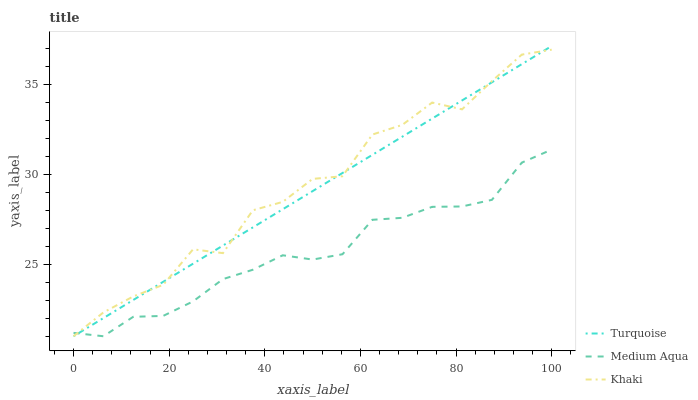Does Medium Aqua have the minimum area under the curve?
Answer yes or no. Yes. Does Khaki have the maximum area under the curve?
Answer yes or no. Yes. Does Khaki have the minimum area under the curve?
Answer yes or no. No. Does Medium Aqua have the maximum area under the curve?
Answer yes or no. No. Is Turquoise the smoothest?
Answer yes or no. Yes. Is Khaki the roughest?
Answer yes or no. Yes. Is Medium Aqua the smoothest?
Answer yes or no. No. Is Medium Aqua the roughest?
Answer yes or no. No. Does Turquoise have the lowest value?
Answer yes or no. Yes. Does Turquoise have the highest value?
Answer yes or no. Yes. Does Khaki have the highest value?
Answer yes or no. No. Does Khaki intersect Turquoise?
Answer yes or no. Yes. Is Khaki less than Turquoise?
Answer yes or no. No. Is Khaki greater than Turquoise?
Answer yes or no. No. 